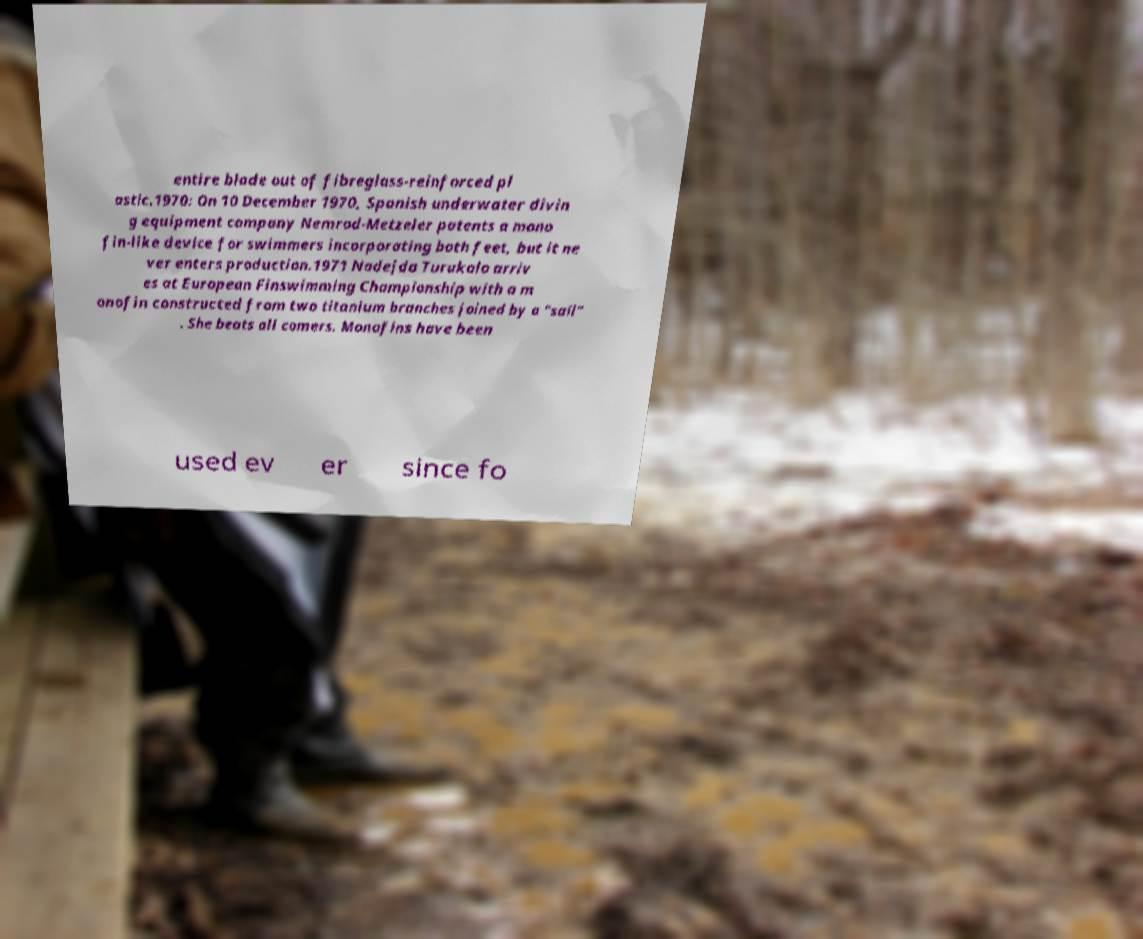Could you extract and type out the text from this image? entire blade out of fibreglass-reinforced pl astic.1970: On 10 December 1970, Spanish underwater divin g equipment company Nemrod-Metzeler patents a mono fin-like device for swimmers incorporating both feet, but it ne ver enters production.1971 Nadejda Turukalo arriv es at European Finswimming Championship with a m onofin constructed from two titanium branches joined by a "sail" . She beats all comers. Monofins have been used ev er since fo 